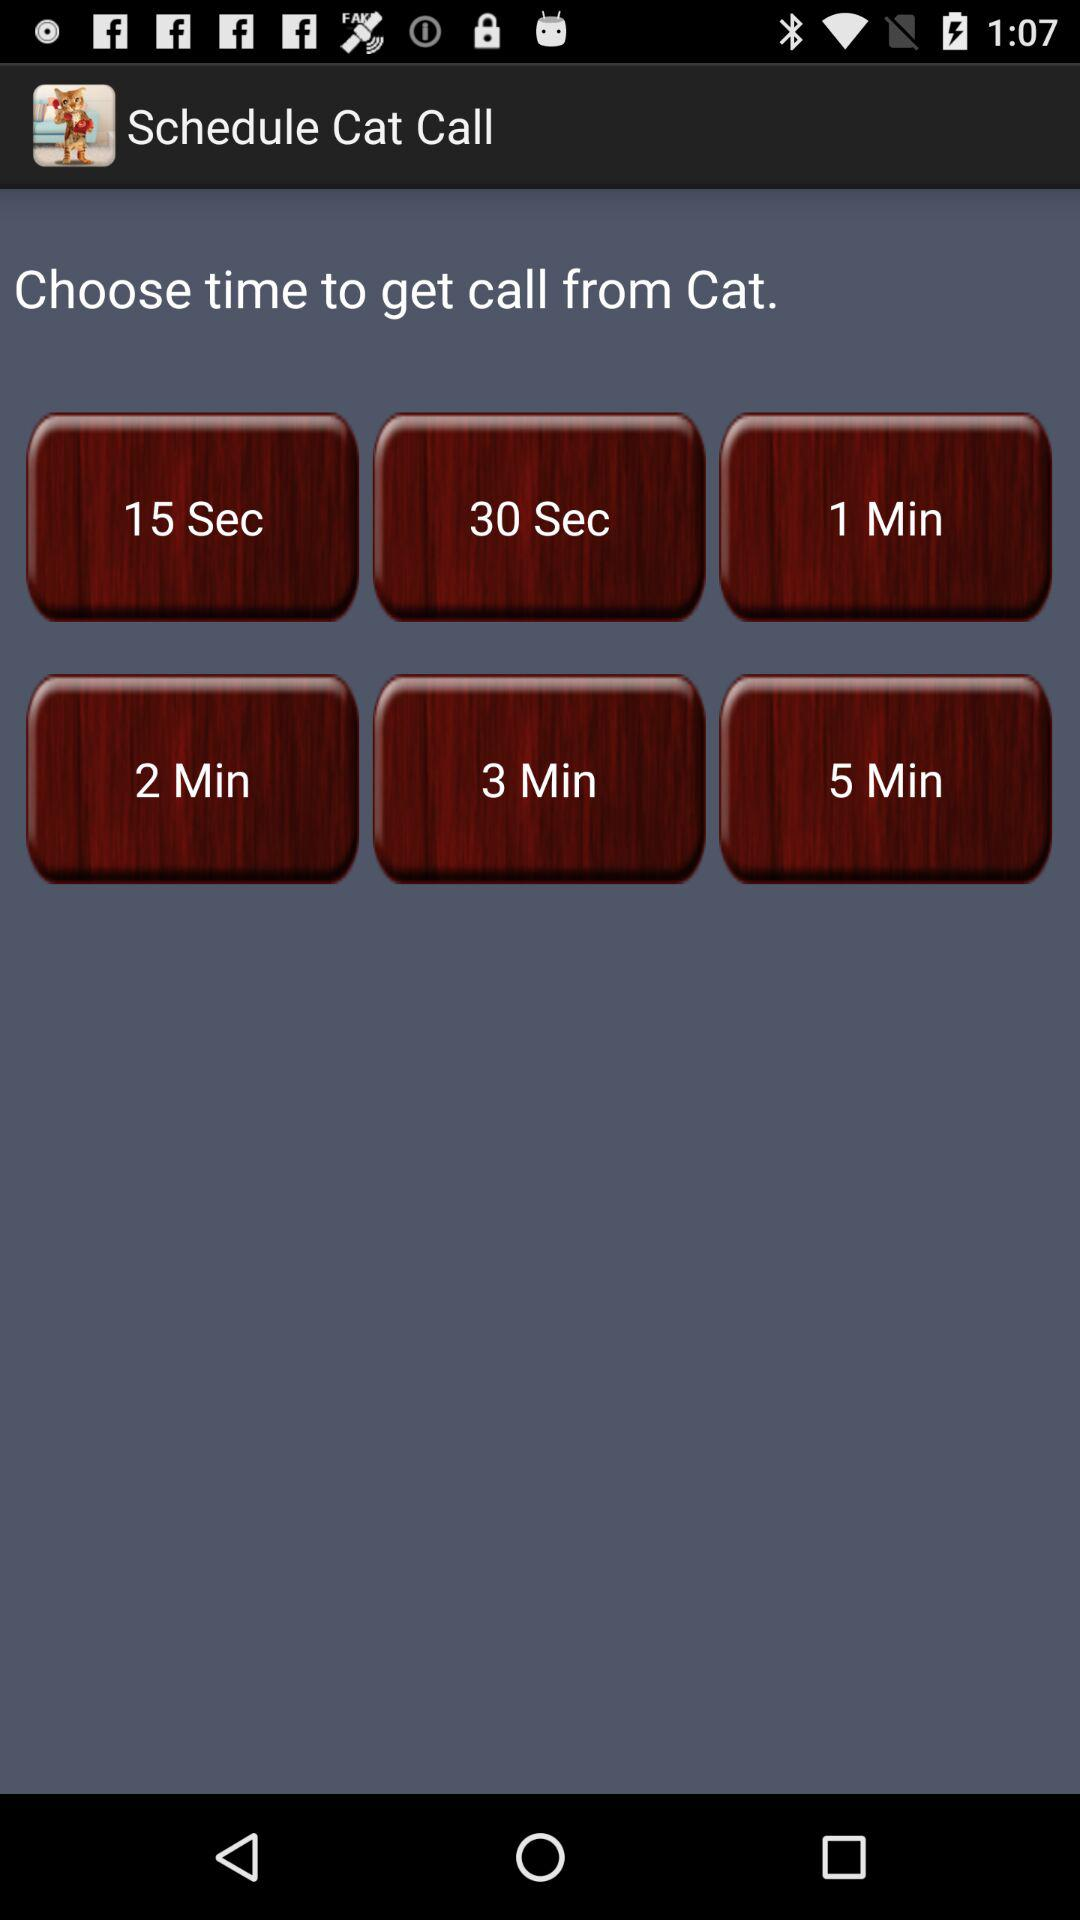What is the name of the application? The application name is "Schedule Cat Call". 